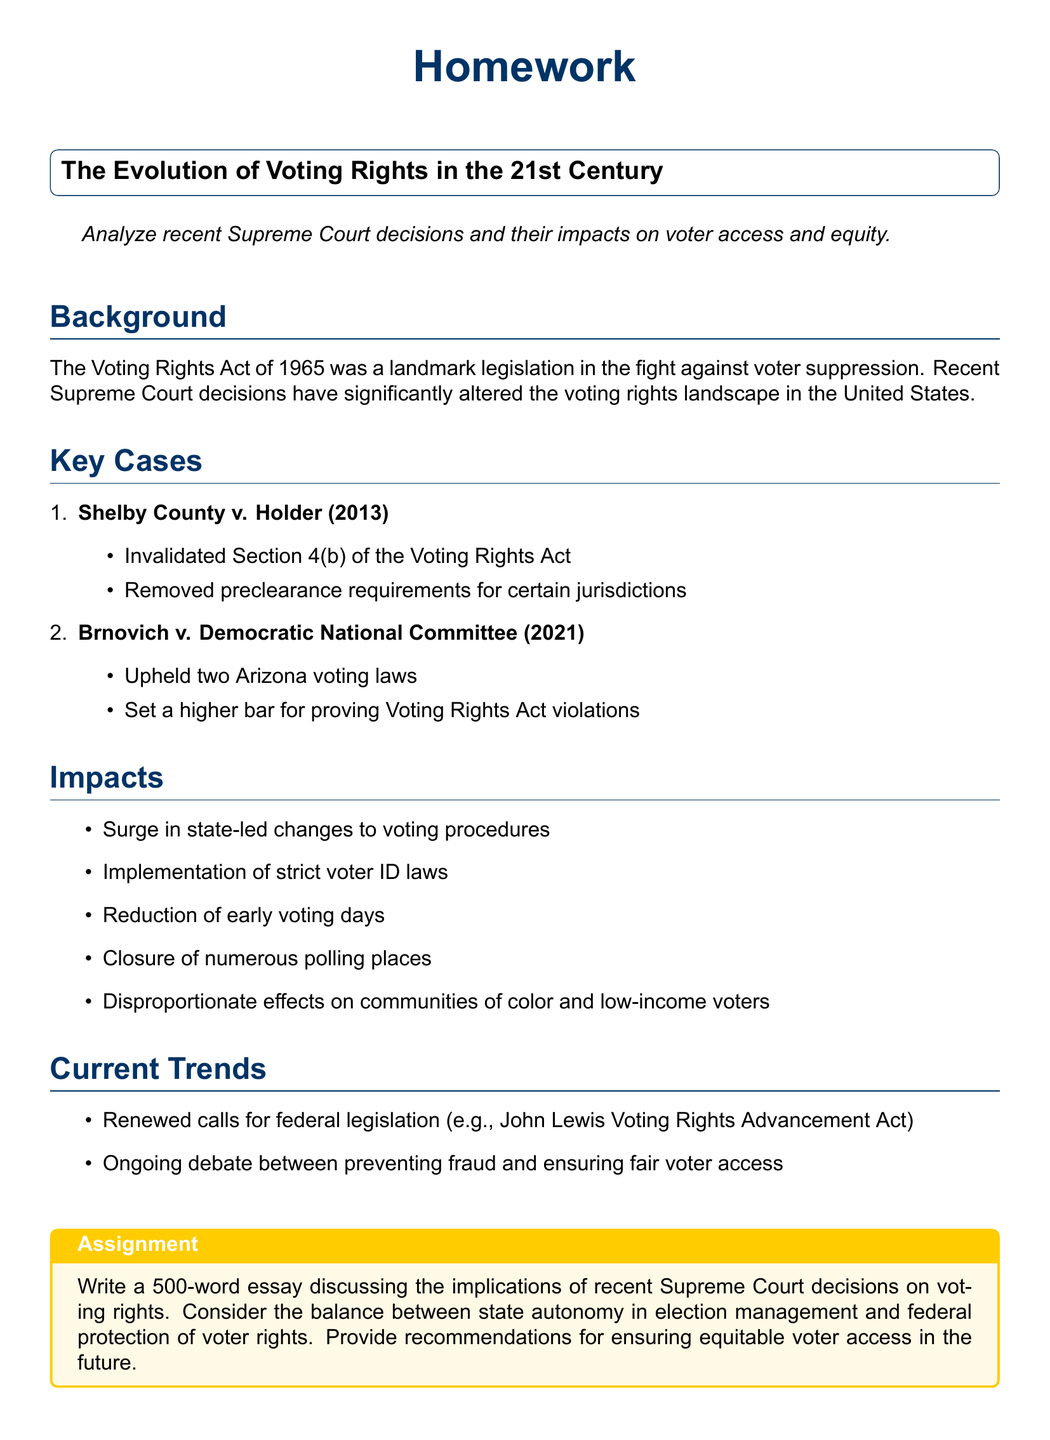what is the landmark legislation mentioned in the document? The document states that the Voting Rights Act of 1965 was a landmark legislation in the fight against voter suppression.
Answer: Voting Rights Act of 1965 what Supreme Court case invalidated Section 4(b) of the Voting Rights Act? The document lists Shelby County v. Holder (2013) as the case that invalidated Section 4(b).
Answer: Shelby County v. Holder (2013) what was upheld in Brnovich v. Democratic National Committee (2021)? The document mentions that the case upheld two Arizona voting laws.
Answer: Two Arizona voting laws what is one impact of recent Supreme Court decisions on voting procedures? The document provides a list of impacts, including the surge in state-led changes to voting procedures.
Answer: Surge in state-led changes how does the document describe the effects on communities of color? The document states that recent changes have had disproportionate effects on communities of color and low-income voters.
Answer: Disproportionate effects what calls are mentioned regarding federal legislation? The document includes renewed calls for federal legislation such as the John Lewis Voting Rights Advancement Act.
Answer: John Lewis Voting Rights Advancement Act how many words should the essay in the assignment be? The assignment specifies that the essay should be 500 words long.
Answer: 500 words what is the primary debate highlighted in the current trends section? The document notes the ongoing debate between preventing fraud and ensuring fair voter access.
Answer: Preventing fraud and ensuring fair voter access what color is used for the box outlining the assignment? The document describes the color used for the assignment box as secondcolor, which is a shade of yellow.
Answer: Second color 